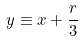Convert formula to latex. <formula><loc_0><loc_0><loc_500><loc_500>y \equiv x + \frac { r } { 3 }</formula> 